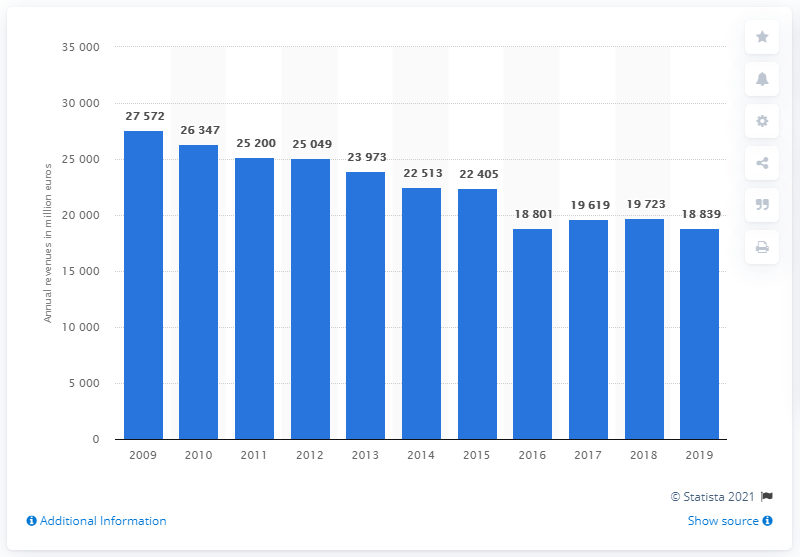List a handful of essential elements in this visual. In the year 2009, the annual revenues of the Italian banking group UniCredit decreased steadily. In 2019, UniCredit's revenue was 18,839. The revenue of UniCredit in 2009 was 27,572. 